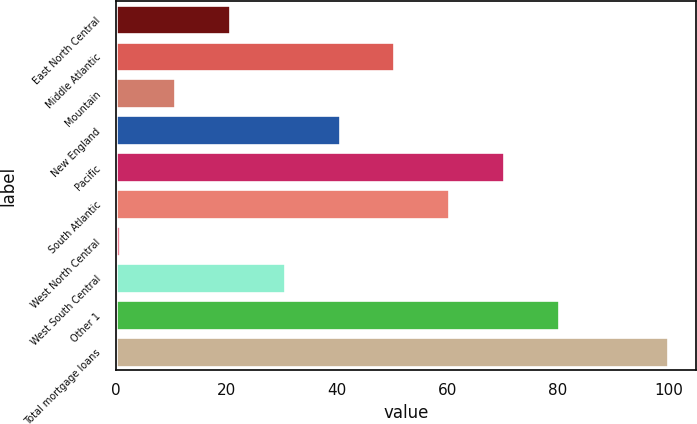Convert chart. <chart><loc_0><loc_0><loc_500><loc_500><bar_chart><fcel>East North Central<fcel>Middle Atlantic<fcel>Mountain<fcel>New England<fcel>Pacific<fcel>South Atlantic<fcel>West North Central<fcel>West South Central<fcel>Other 1<fcel>Total mortgage loans<nl><fcel>20.64<fcel>50.4<fcel>10.72<fcel>40.48<fcel>70.24<fcel>60.32<fcel>0.8<fcel>30.56<fcel>80.16<fcel>100<nl></chart> 